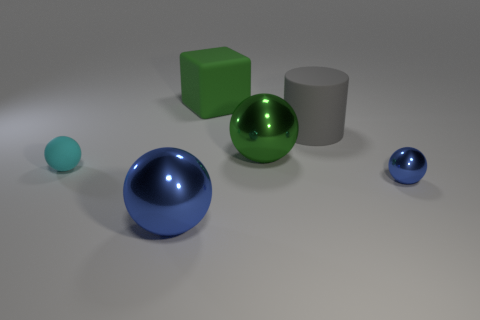What is the color of the tiny shiny object that is the same shape as the big green shiny object?
Your answer should be very brief. Blue. Is the number of blue spheres that are in front of the tiny blue metal sphere greater than the number of large brown cubes?
Offer a very short reply. Yes. There is a small matte thing; is its shape the same as the large metallic thing behind the cyan matte sphere?
Your answer should be compact. Yes. The green thing that is the same shape as the tiny cyan rubber object is what size?
Give a very brief answer. Large. Is the number of cyan spheres greater than the number of green matte cylinders?
Give a very brief answer. Yes. Is the cyan matte object the same shape as the small blue thing?
Your answer should be very brief. Yes. There is a big sphere that is right of the blue shiny object that is in front of the tiny blue sphere; what is its material?
Ensure brevity in your answer.  Metal. Is the green ball the same size as the cyan rubber thing?
Your answer should be compact. No. There is a gray object to the right of the cyan thing; is there a sphere that is on the left side of it?
Make the answer very short. Yes. What size is the sphere that is the same color as the matte block?
Your answer should be compact. Large. 